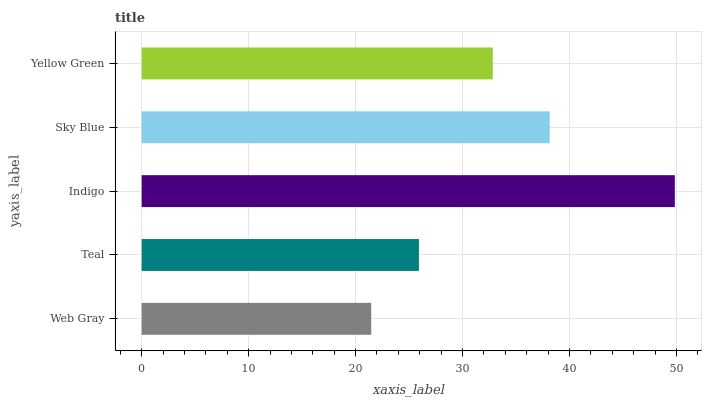Is Web Gray the minimum?
Answer yes or no. Yes. Is Indigo the maximum?
Answer yes or no. Yes. Is Teal the minimum?
Answer yes or no. No. Is Teal the maximum?
Answer yes or no. No. Is Teal greater than Web Gray?
Answer yes or no. Yes. Is Web Gray less than Teal?
Answer yes or no. Yes. Is Web Gray greater than Teal?
Answer yes or no. No. Is Teal less than Web Gray?
Answer yes or no. No. Is Yellow Green the high median?
Answer yes or no. Yes. Is Yellow Green the low median?
Answer yes or no. Yes. Is Teal the high median?
Answer yes or no. No. Is Teal the low median?
Answer yes or no. No. 